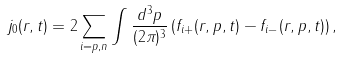Convert formula to latex. <formula><loc_0><loc_0><loc_500><loc_500>j _ { 0 } ( { r } , t ) = 2 \sum _ { i = p , n } \int \frac { d ^ { 3 } p } { ( 2 \pi ) ^ { 3 } } \, ( f _ { i + } ( { r } , { p } , t ) - f _ { i - } ( { r } , { p } , t ) ) \, ,</formula> 